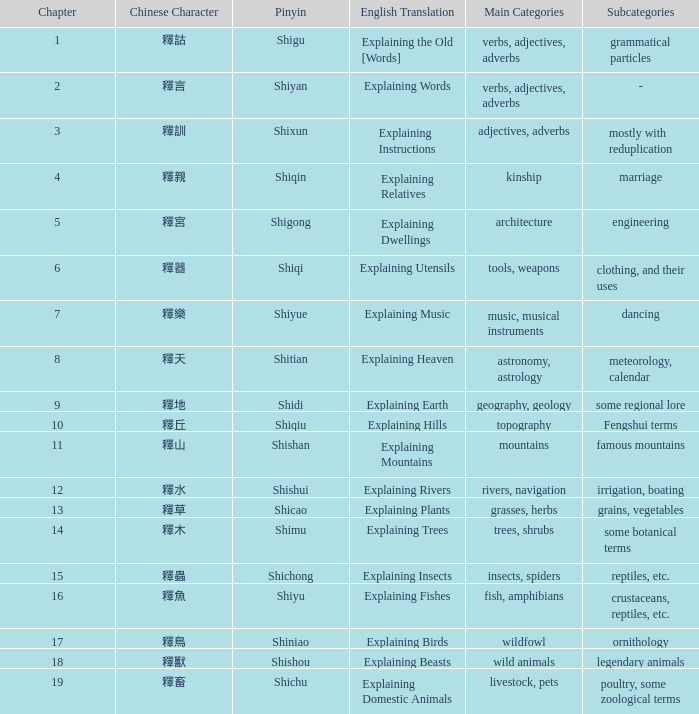Name the total number of chapter for chinese of 釋宮 1.0. 